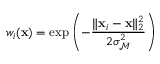<formula> <loc_0><loc_0><loc_500><loc_500>w _ { i } ( x ) = \exp \left ( - \frac { \| x _ { i } - x \| _ { 2 } ^ { 2 } } { 2 \sigma _ { \mathcal { M } } ^ { 2 } } \right )</formula> 